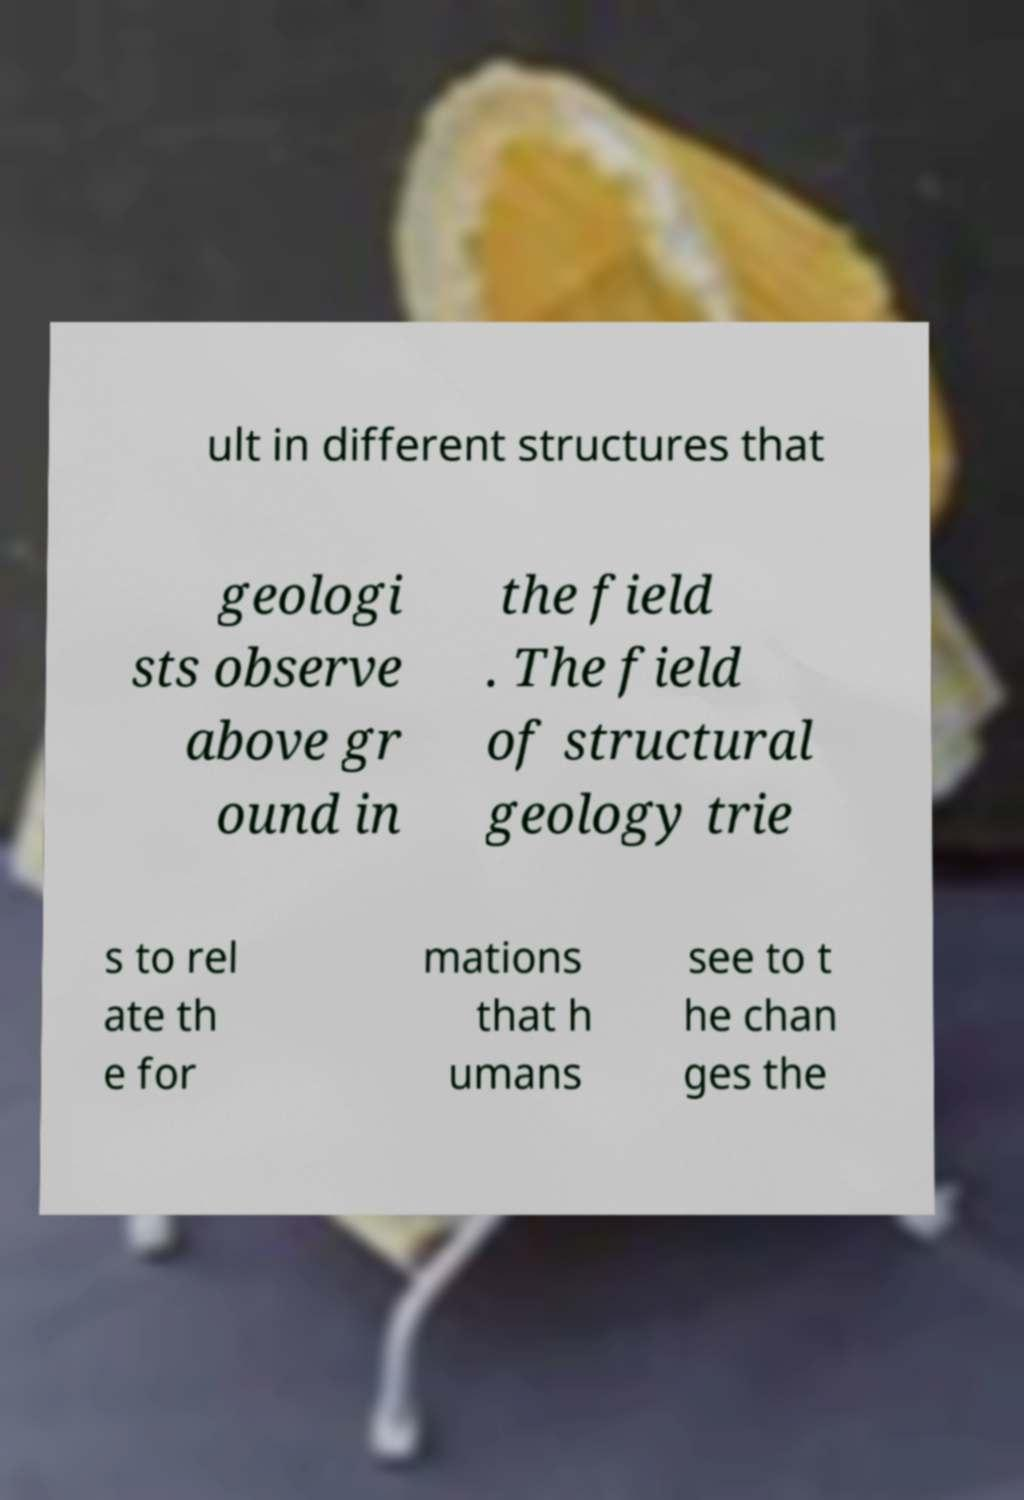Could you assist in decoding the text presented in this image and type it out clearly? ult in different structures that geologi sts observe above gr ound in the field . The field of structural geology trie s to rel ate th e for mations that h umans see to t he chan ges the 